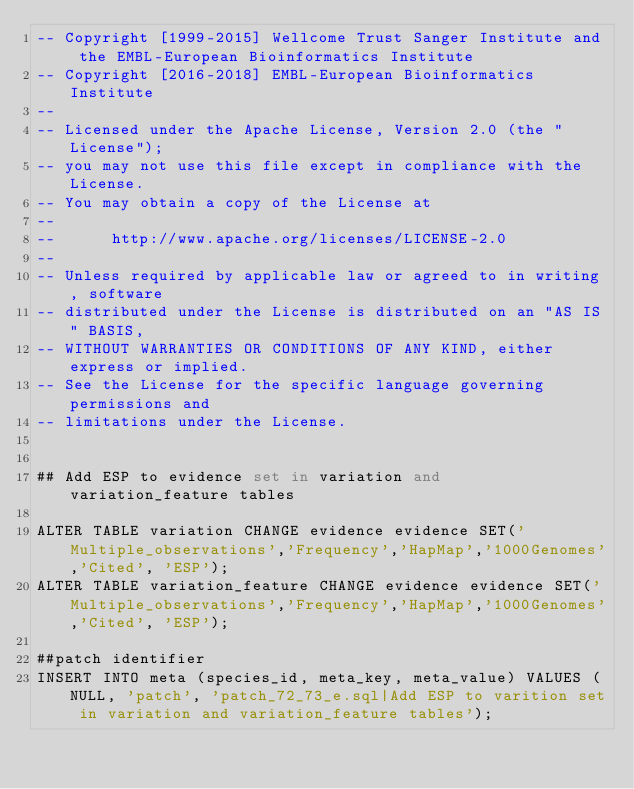<code> <loc_0><loc_0><loc_500><loc_500><_SQL_>-- Copyright [1999-2015] Wellcome Trust Sanger Institute and the EMBL-European Bioinformatics Institute
-- Copyright [2016-2018] EMBL-European Bioinformatics Institute
-- 
-- Licensed under the Apache License, Version 2.0 (the "License");
-- you may not use this file except in compliance with the License.
-- You may obtain a copy of the License at
-- 
--      http://www.apache.org/licenses/LICENSE-2.0
-- 
-- Unless required by applicable law or agreed to in writing, software
-- distributed under the License is distributed on an "AS IS" BASIS,
-- WITHOUT WARRANTIES OR CONDITIONS OF ANY KIND, either express or implied.
-- See the License for the specific language governing permissions and
-- limitations under the License.


## Add ESP to evidence set in variation and variation_feature tables

ALTER TABLE variation CHANGE evidence evidence SET('Multiple_observations','Frequency','HapMap','1000Genomes','Cited', 'ESP');
ALTER TABLE variation_feature CHANGE evidence evidence SET('Multiple_observations','Frequency','HapMap','1000Genomes','Cited', 'ESP');

##patch identifier
INSERT INTO meta (species_id, meta_key, meta_value) VALUES (NULL, 'patch', 'patch_72_73_e.sql|Add ESP to varition set in variation and variation_feature tables');
</code> 